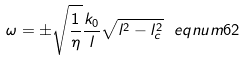<formula> <loc_0><loc_0><loc_500><loc_500>\omega = \pm \sqrt { \frac { 1 } { \eta } } \frac { k _ { 0 } } { l } \sqrt { l ^ { 2 } - l _ { c } ^ { 2 } } \ e q n u m { 6 2 }</formula> 